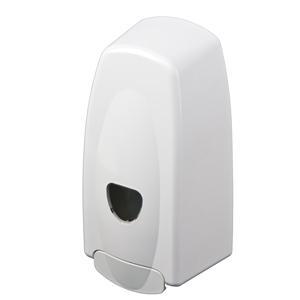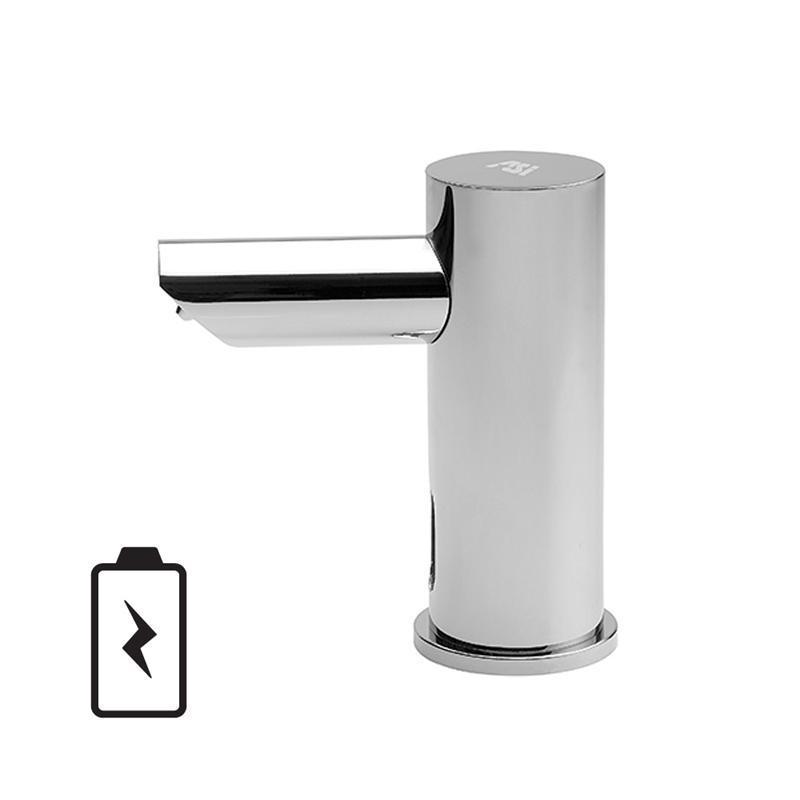The first image is the image on the left, the second image is the image on the right. Considering the images on both sides, is "One of these is silver in color." valid? Answer yes or no. Yes. The first image is the image on the left, the second image is the image on the right. Considering the images on both sides, is "An image features a cylindrical dispenser with chrome finish." valid? Answer yes or no. Yes. 